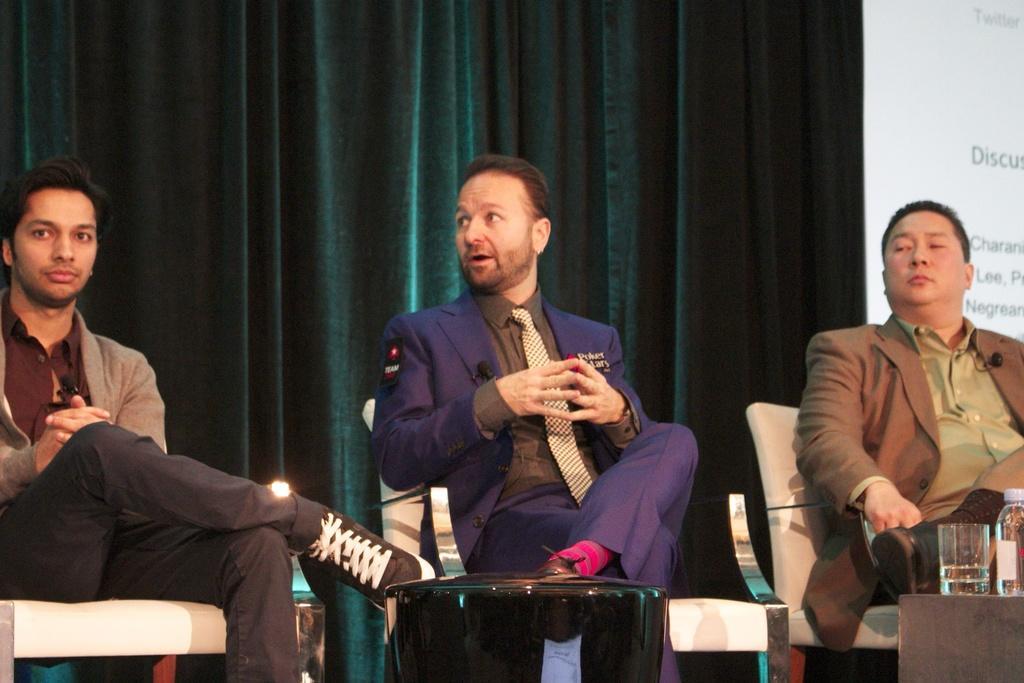Please provide a concise description of this image. In the picture there are three men sitting on the chair, in front of them there is a table, on the table there is a glass and a bottle, behind them there is a curtain, there is a screen with the text on the wall. 